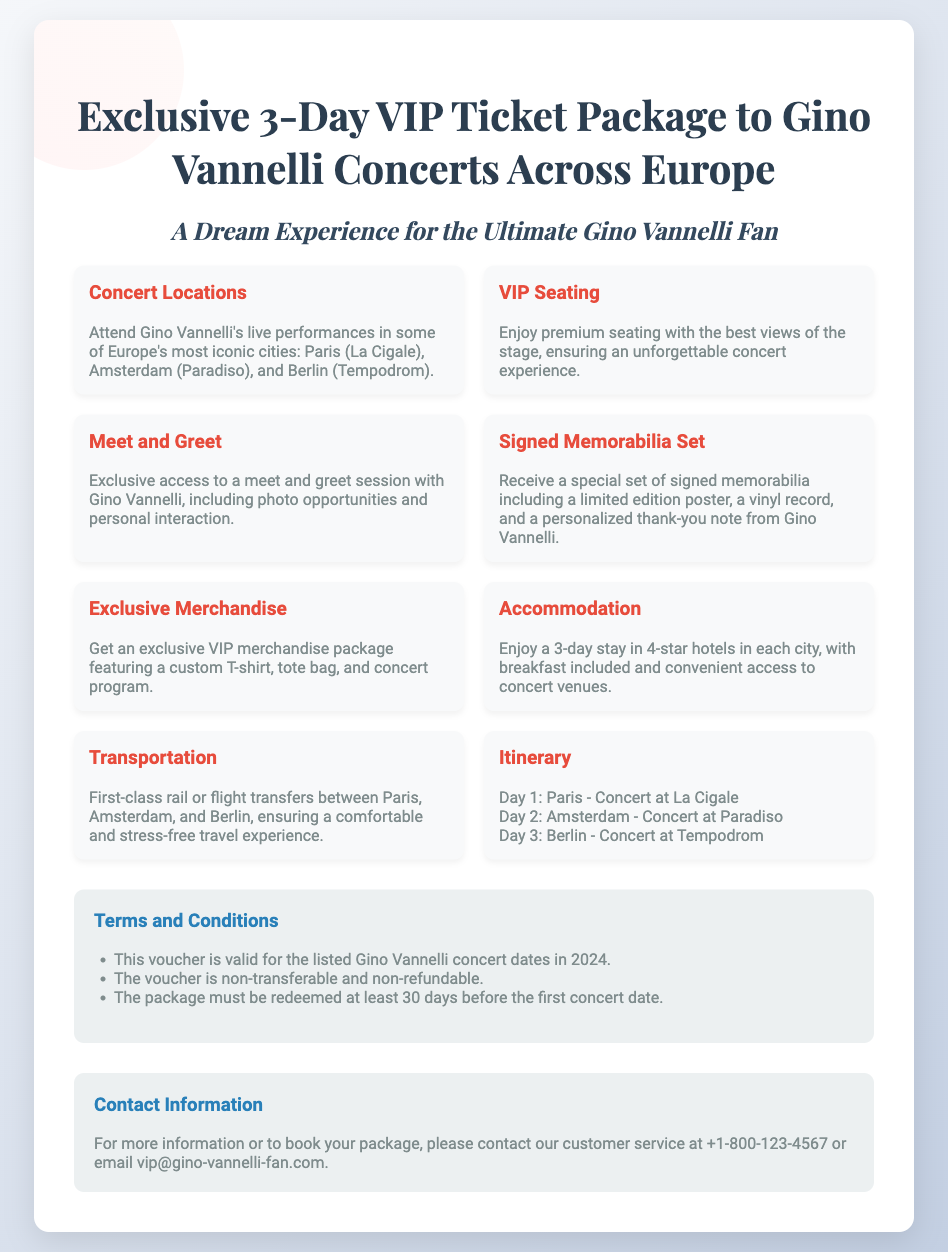What are the concert locations? The concert locations are specified in the document, listing Paris, Amsterdam, and Berlin.
Answer: Paris, Amsterdam, Berlin How many days does the VIP package include? The package is described as a 3-day VIP Ticket Package.
Answer: 3 days What kind of seating is provided? The document mentions that VIP seating is offered, ensuring the best views of the stage.
Answer: Premium seating What does the signed memorabilia set include? The details mention a limited edition poster, a vinyl record, and a personalized thank-you note.
Answer: Limited edition poster, vinyl record, personalized note What type of transportation is included in the package? The document states first-class rail or flight transfers are included for traveling between the concert cities.
Answer: First-class rail or flight How many concert venues are listed in the itinerary? The itinerary includes details of concerts in three different cities or venues.
Answer: Three venues What is required to redeem the voucher before the concerts? The document specifies that the package must be redeemed at least 30 days before the first concert date.
Answer: 30 days Is the voucher transferable? The terms and conditions highlight that the voucher is non-transferable.
Answer: Non-transferable 